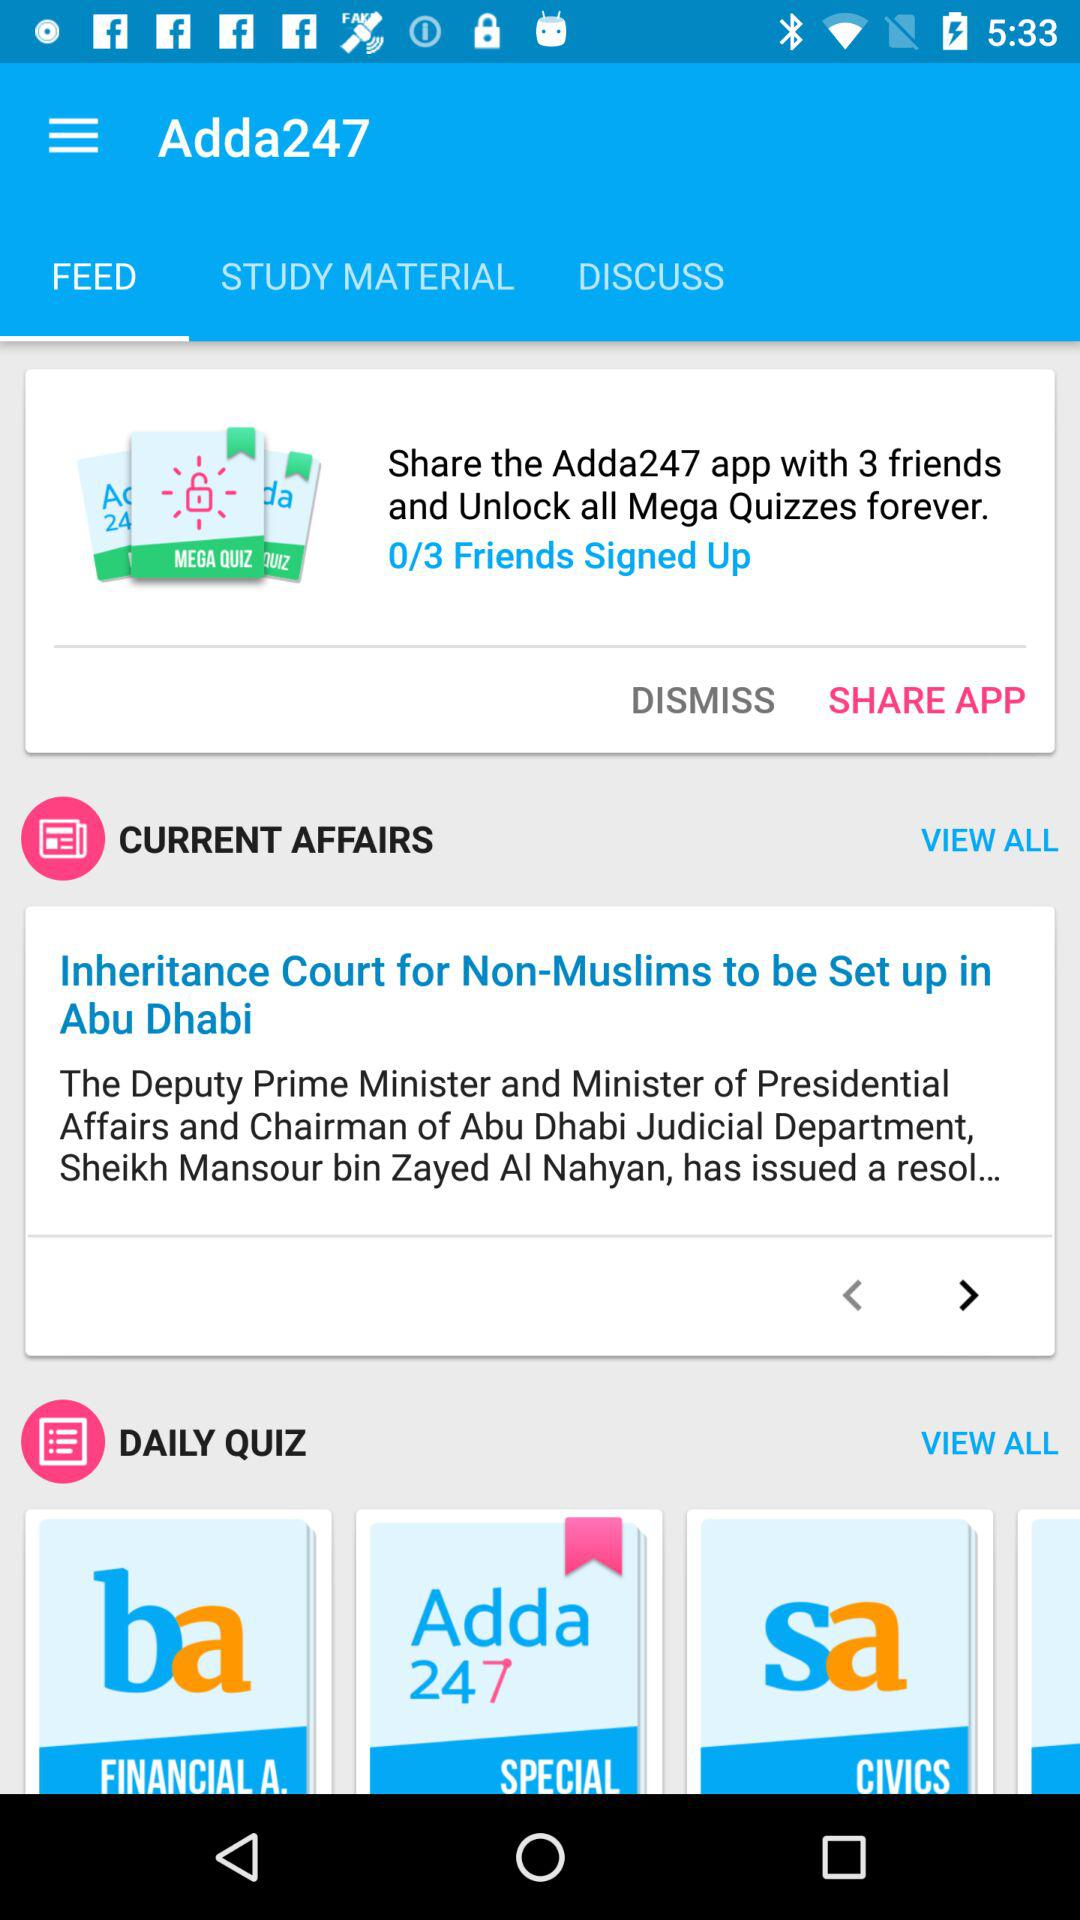What is the name of the application? The application name is "Adda247". 